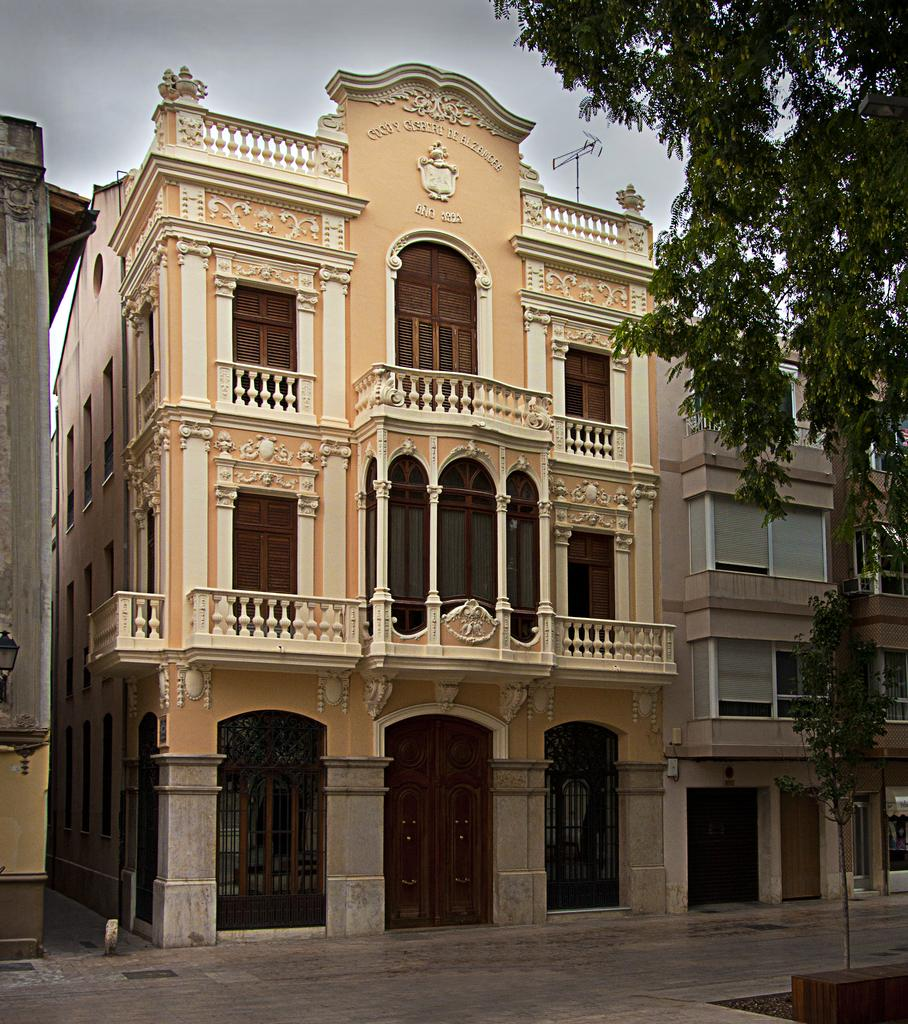What type of vegetation is on the right side of the image? There is a tree on the right side of the image. What can be seen in the background of the image? There are buildings in the background of the image. What is the main structure in the image? There is a 2-storey building at the center of the image. What features does the 2-storey building have? The 2-storey building has doors. How many frogs are sitting on the tree in the image? There are no frogs present in the image; it features a tree and a 2-storey building. What type of territory does the turkey occupy in the image? There is no turkey present in the image; it features a tree and a 2-storey building. 